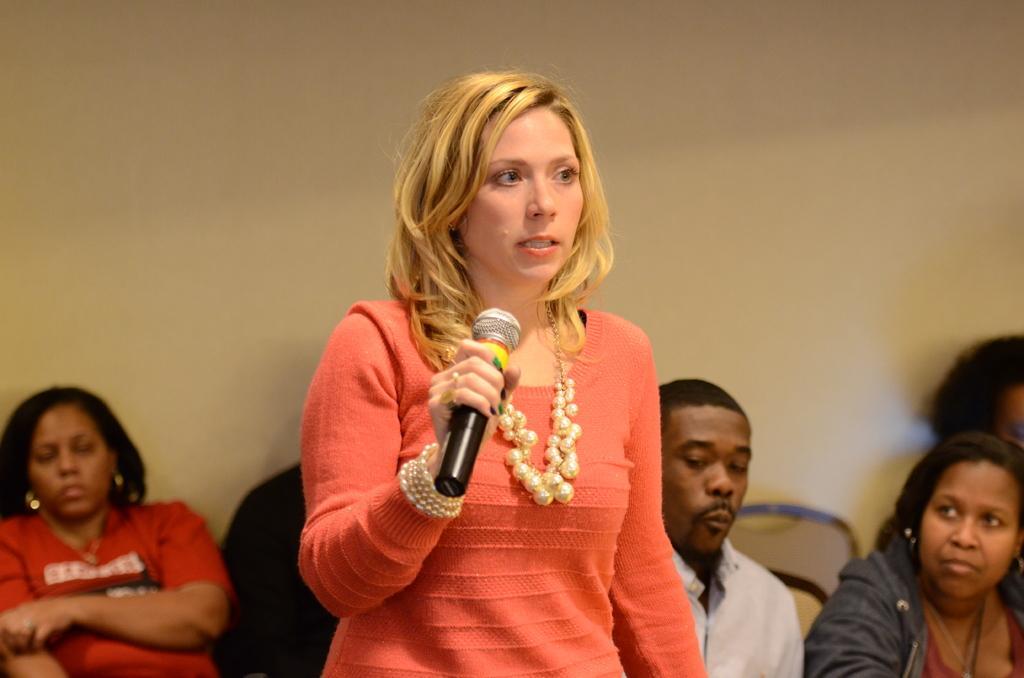Can you describe this image briefly? As we can see in the image there are people sitting and there is a lady infront who is standing and holding a mike in her hand. At the background there is a cream colour wall. 